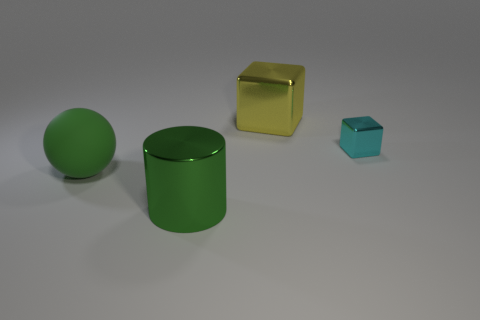Add 2 small cyan cubes. How many objects exist? 6 Subtract all cylinders. How many objects are left? 3 Subtract all small matte things. Subtract all cyan blocks. How many objects are left? 3 Add 3 cyan metallic things. How many cyan metallic things are left? 4 Add 4 large green matte balls. How many large green matte balls exist? 5 Subtract 0 red blocks. How many objects are left? 4 